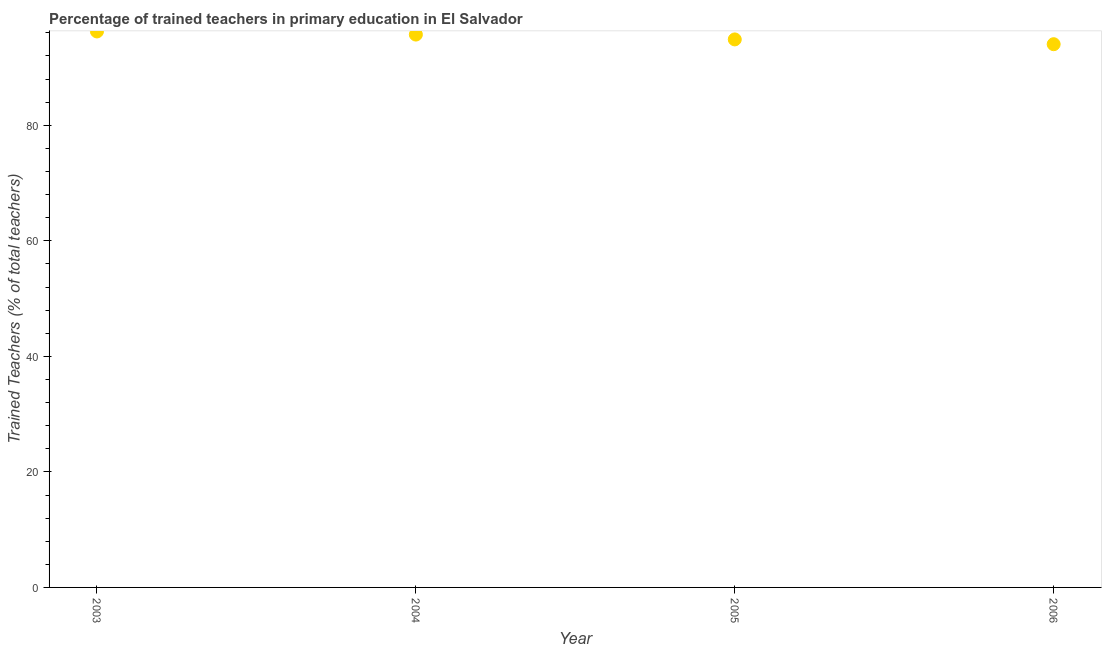What is the percentage of trained teachers in 2003?
Give a very brief answer. 96.25. Across all years, what is the maximum percentage of trained teachers?
Provide a succinct answer. 96.25. Across all years, what is the minimum percentage of trained teachers?
Offer a very short reply. 94.04. In which year was the percentage of trained teachers maximum?
Keep it short and to the point. 2003. What is the sum of the percentage of trained teachers?
Ensure brevity in your answer.  380.87. What is the difference between the percentage of trained teachers in 2005 and 2006?
Make the answer very short. 0.83. What is the average percentage of trained teachers per year?
Give a very brief answer. 95.22. What is the median percentage of trained teachers?
Provide a succinct answer. 95.29. What is the ratio of the percentage of trained teachers in 2004 to that in 2005?
Your answer should be compact. 1.01. What is the difference between the highest and the second highest percentage of trained teachers?
Offer a very short reply. 0.54. Is the sum of the percentage of trained teachers in 2003 and 2004 greater than the maximum percentage of trained teachers across all years?
Provide a succinct answer. Yes. What is the difference between the highest and the lowest percentage of trained teachers?
Keep it short and to the point. 2.21. In how many years, is the percentage of trained teachers greater than the average percentage of trained teachers taken over all years?
Keep it short and to the point. 2. Does the percentage of trained teachers monotonically increase over the years?
Provide a succinct answer. No. How many dotlines are there?
Your answer should be compact. 1. How many years are there in the graph?
Keep it short and to the point. 4. Does the graph contain any zero values?
Make the answer very short. No. What is the title of the graph?
Your answer should be very brief. Percentage of trained teachers in primary education in El Salvador. What is the label or title of the Y-axis?
Your answer should be compact. Trained Teachers (% of total teachers). What is the Trained Teachers (% of total teachers) in 2003?
Your response must be concise. 96.25. What is the Trained Teachers (% of total teachers) in 2004?
Make the answer very short. 95.71. What is the Trained Teachers (% of total teachers) in 2005?
Provide a succinct answer. 94.87. What is the Trained Teachers (% of total teachers) in 2006?
Your response must be concise. 94.04. What is the difference between the Trained Teachers (% of total teachers) in 2003 and 2004?
Keep it short and to the point. 0.54. What is the difference between the Trained Teachers (% of total teachers) in 2003 and 2005?
Provide a succinct answer. 1.38. What is the difference between the Trained Teachers (% of total teachers) in 2003 and 2006?
Provide a succinct answer. 2.21. What is the difference between the Trained Teachers (% of total teachers) in 2004 and 2005?
Your response must be concise. 0.84. What is the difference between the Trained Teachers (% of total teachers) in 2004 and 2006?
Ensure brevity in your answer.  1.67. What is the difference between the Trained Teachers (% of total teachers) in 2005 and 2006?
Keep it short and to the point. 0.83. What is the ratio of the Trained Teachers (% of total teachers) in 2003 to that in 2005?
Ensure brevity in your answer.  1.01. What is the ratio of the Trained Teachers (% of total teachers) in 2005 to that in 2006?
Your response must be concise. 1.01. 